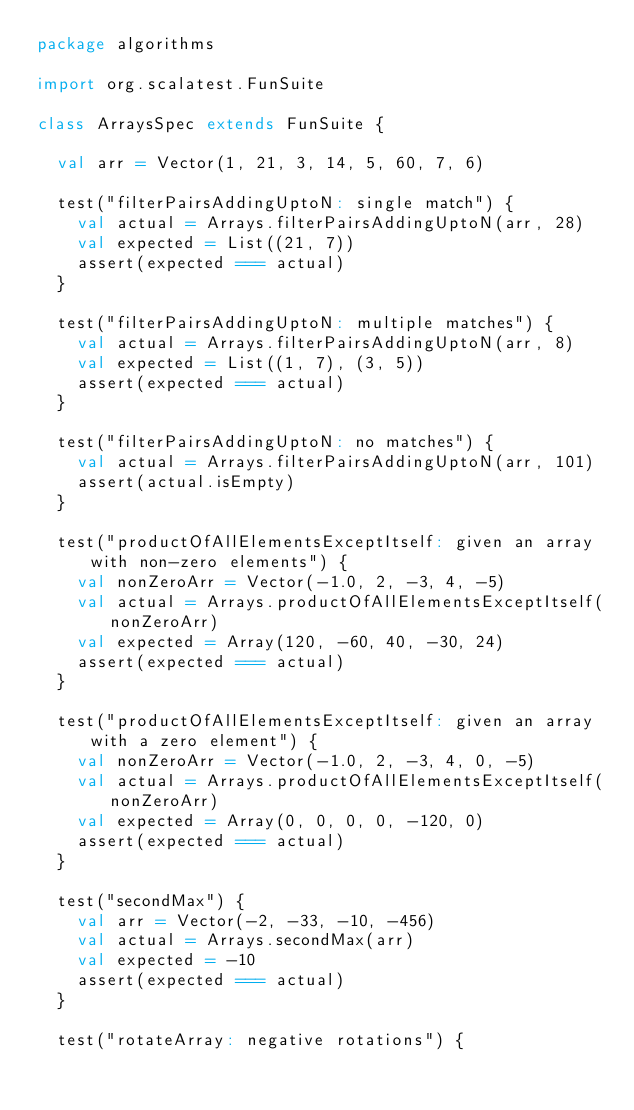<code> <loc_0><loc_0><loc_500><loc_500><_Scala_>package algorithms

import org.scalatest.FunSuite

class ArraysSpec extends FunSuite {

  val arr = Vector(1, 21, 3, 14, 5, 60, 7, 6)

  test("filterPairsAddingUptoN: single match") {
    val actual = Arrays.filterPairsAddingUptoN(arr, 28)
    val expected = List((21, 7))
    assert(expected === actual)
  }

  test("filterPairsAddingUptoN: multiple matches") {
    val actual = Arrays.filterPairsAddingUptoN(arr, 8)
    val expected = List((1, 7), (3, 5))
    assert(expected === actual)
  }

  test("filterPairsAddingUptoN: no matches") {
    val actual = Arrays.filterPairsAddingUptoN(arr, 101)
    assert(actual.isEmpty)
  }

  test("productOfAllElementsExceptItself: given an array with non-zero elements") {
    val nonZeroArr = Vector(-1.0, 2, -3, 4, -5)
    val actual = Arrays.productOfAllElementsExceptItself(nonZeroArr)
    val expected = Array(120, -60, 40, -30, 24)
    assert(expected === actual)
  }

  test("productOfAllElementsExceptItself: given an array with a zero element") {
    val nonZeroArr = Vector(-1.0, 2, -3, 4, 0, -5)
    val actual = Arrays.productOfAllElementsExceptItself(nonZeroArr)
    val expected = Array(0, 0, 0, 0, -120, 0)
    assert(expected === actual)
  }

  test("secondMax") {
    val arr = Vector(-2, -33, -10, -456)
    val actual = Arrays.secondMax(arr)
    val expected = -10
    assert(expected === actual)
  }

  test("rotateArray: negative rotations") {</code> 